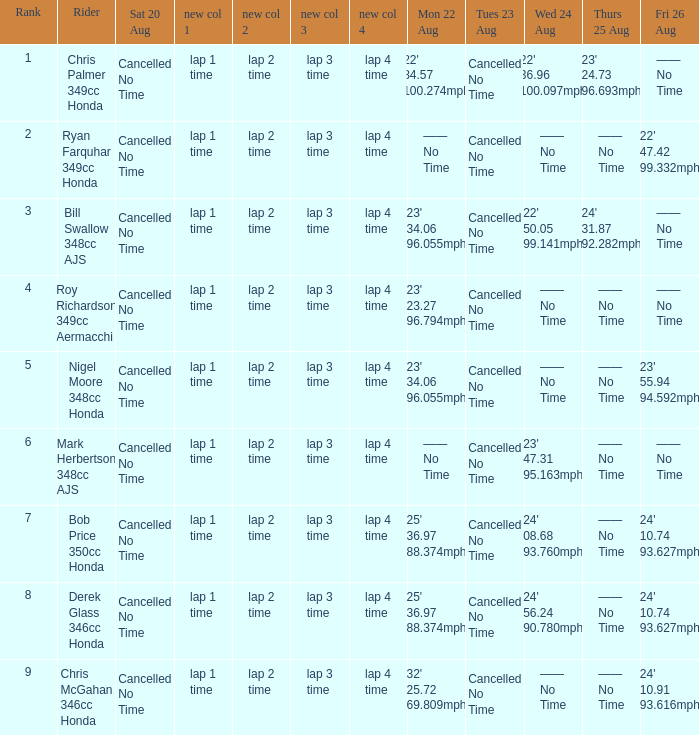What is every entry for Tuesday August 23 when Thursday August 25 is 24' 31.87 92.282mph? Cancelled No Time. 